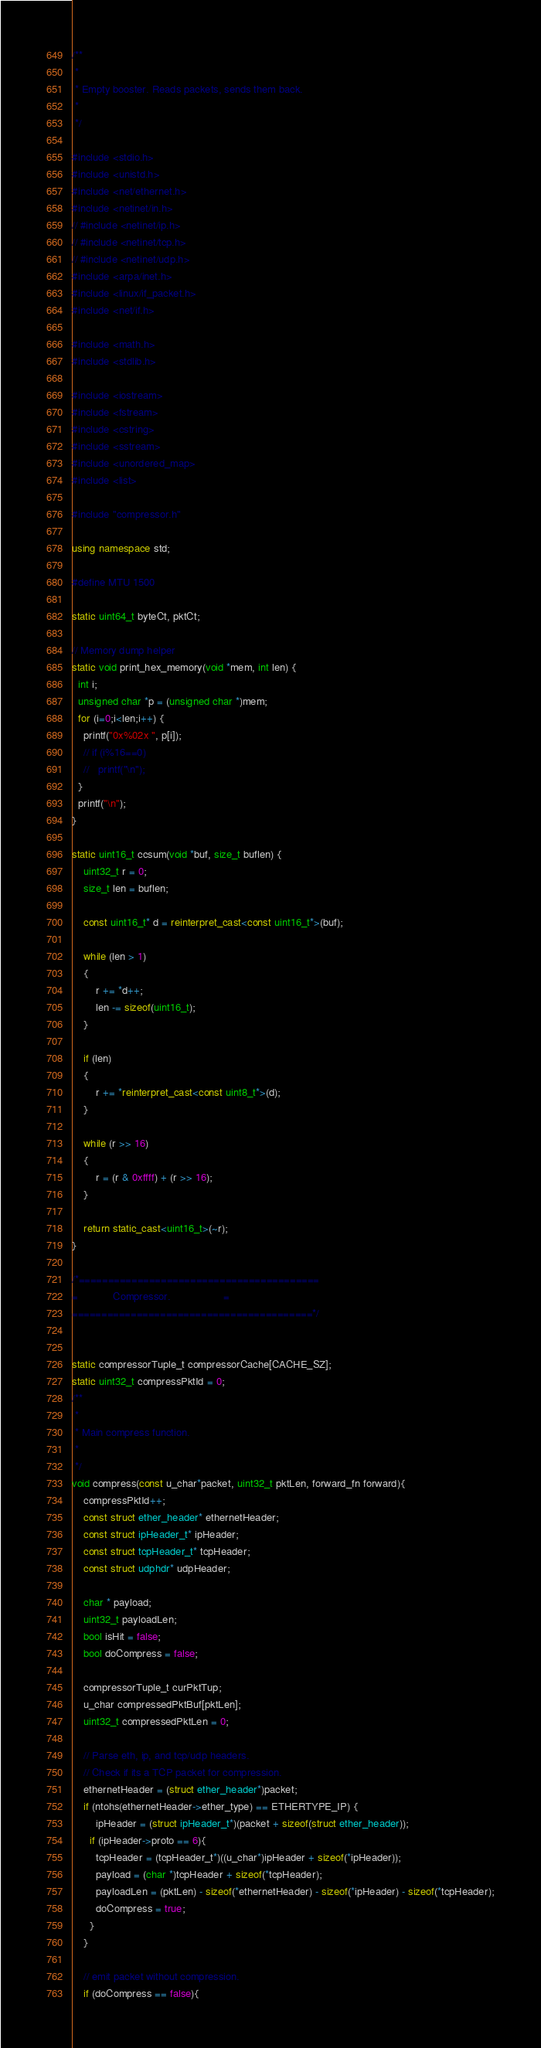Convert code to text. <code><loc_0><loc_0><loc_500><loc_500><_C++_>/**
 *
 * Empty booster. Reads packets, sends them back.
 *
 */

#include <stdio.h>
#include <unistd.h>
#include <net/ethernet.h>
#include <netinet/in.h>
// #include <netinet/ip.h>
// #include <netinet/tcp.h>
// #include <netinet/udp.h>
#include <arpa/inet.h>
#include <linux/if_packet.h>
#include <net/if.h>

#include <math.h>
#include <stdlib.h>

#include <iostream>
#include <fstream>
#include <cstring>
#include <sstream>
#include <unordered_map>
#include <list>

#include "compressor.h"

using namespace std;

#define MTU 1500

static uint64_t byteCt, pktCt;

// Memory dump helper
static void print_hex_memory(void *mem, int len) {
  int i;
  unsigned char *p = (unsigned char *)mem;
  for (i=0;i<len;i++) {
    printf("0x%02x ", p[i]);
    // if (i%16==0)
    //   printf("\n");
  }
  printf("\n");
}

static uint16_t ccsum(void *buf, size_t buflen) {
    uint32_t r = 0;
    size_t len = buflen;

    const uint16_t* d = reinterpret_cast<const uint16_t*>(buf);

    while (len > 1)
    {
        r += *d++;
        len -= sizeof(uint16_t);
    }

    if (len)
    {
        r += *reinterpret_cast<const uint8_t*>(d);
    }

    while (r >> 16)
    {
        r = (r & 0xffff) + (r >> 16);
    }

    return static_cast<uint16_t>(~r);
}

/*=========================================
=            Compressor.                  =
=========================================*/


static compressorTuple_t compressorCache[CACHE_SZ];
static uint32_t compressPktId = 0;
/**
 *
 * Main compress function.
 *
 */
void compress(const u_char*packet, uint32_t pktLen, forward_fn forward){
    compressPktId++;
    const struct ether_header* ethernetHeader;
    const struct ipHeader_t* ipHeader;
    const struct tcpHeader_t* tcpHeader;
    const struct udphdr* udpHeader;

    char * payload;
    uint32_t payloadLen;
    bool isHit = false;
    bool doCompress = false;

    compressorTuple_t curPktTup;
    u_char compressedPktBuf[pktLen];
    uint32_t compressedPktLen = 0;

    // Parse eth, ip, and tcp/udp headers.
    // Check if its a TCP packet for compression.
    ethernetHeader = (struct ether_header*)packet;
    if (ntohs(ethernetHeader->ether_type) == ETHERTYPE_IP) {
        ipHeader = (struct ipHeader_t*)(packet + sizeof(struct ether_header));
      if (ipHeader->proto == 6){
        tcpHeader = (tcpHeader_t*)((u_char*)ipHeader + sizeof(*ipHeader));
        payload = (char *)tcpHeader + sizeof(*tcpHeader);
        payloadLen = (pktLen) - sizeof(*ethernetHeader) - sizeof(*ipHeader) - sizeof(*tcpHeader);
        doCompress = true;
      }
    }

    // emit packet without compression.
    if (doCompress == false){</code> 